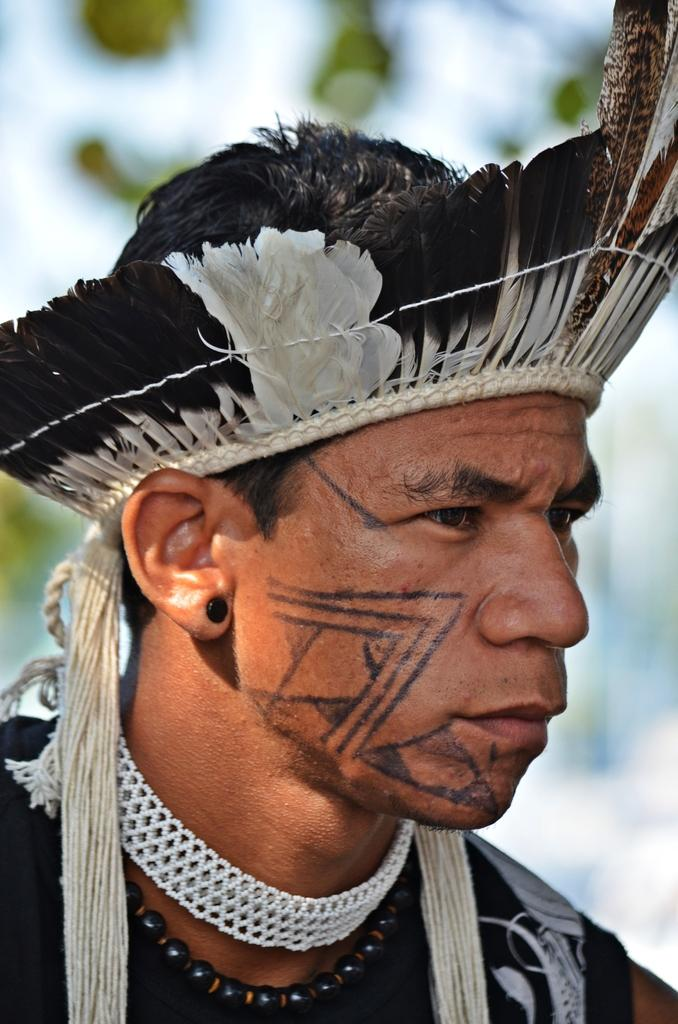What is present in the image? There is a man in the image. Can you describe what the man is wearing on his head? The man is wearing a feather hat. What type of plane can be seen flying in the image? There is no plane visible in the image; it only features a man wearing a feather hat. Is there any poison present in the image? There is no mention of poison in the image; it only features a man wearing a feather hat. 